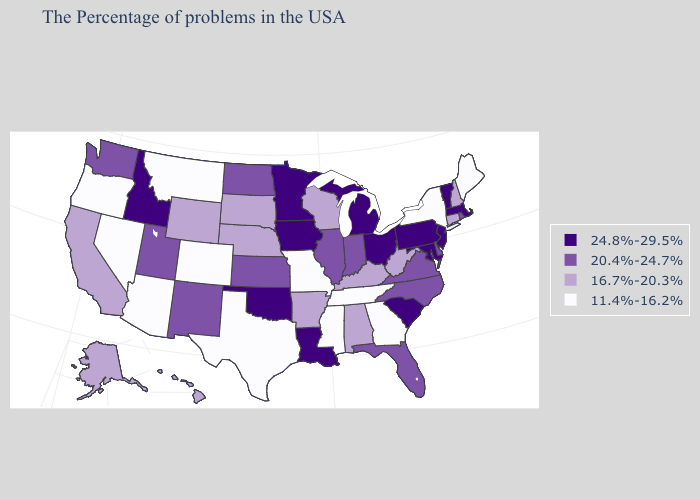How many symbols are there in the legend?
Give a very brief answer. 4. What is the highest value in the USA?
Short answer required. 24.8%-29.5%. What is the lowest value in states that border Illinois?
Quick response, please. 11.4%-16.2%. Does Mississippi have the lowest value in the USA?
Answer briefly. Yes. What is the value of Delaware?
Concise answer only. 20.4%-24.7%. Does North Carolina have the lowest value in the USA?
Give a very brief answer. No. How many symbols are there in the legend?
Short answer required. 4. Is the legend a continuous bar?
Answer briefly. No. What is the highest value in states that border Wyoming?
Give a very brief answer. 24.8%-29.5%. Among the states that border Montana , which have the highest value?
Concise answer only. Idaho. Name the states that have a value in the range 11.4%-16.2%?
Concise answer only. Maine, New York, Georgia, Tennessee, Mississippi, Missouri, Texas, Colorado, Montana, Arizona, Nevada, Oregon. What is the value of Rhode Island?
Short answer required. 20.4%-24.7%. Name the states that have a value in the range 20.4%-24.7%?
Answer briefly. Rhode Island, Delaware, Virginia, North Carolina, Florida, Indiana, Illinois, Kansas, North Dakota, New Mexico, Utah, Washington. 